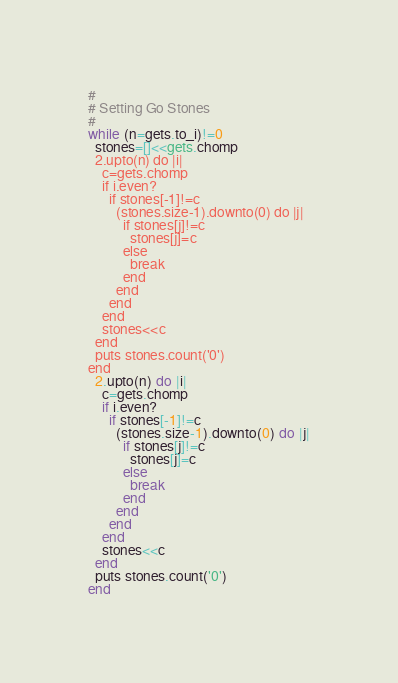Convert code to text. <code><loc_0><loc_0><loc_500><loc_500><_Ruby_>#
# Setting Go Stones
#
while (n=gets.to_i)!=0
  stones=[]<<gets.chomp
  2.upto(n) do |i|
    c=gets.chomp
    if i.even?
      if stones[-1]!=c
        (stones.size-1).downto(0) do |j|
          if stones[j]!=c
            stones[j]=c
          else
            break
          end
        end
      end
    end
    stones<<c
  end
  puts stones.count('0')
end</code> 